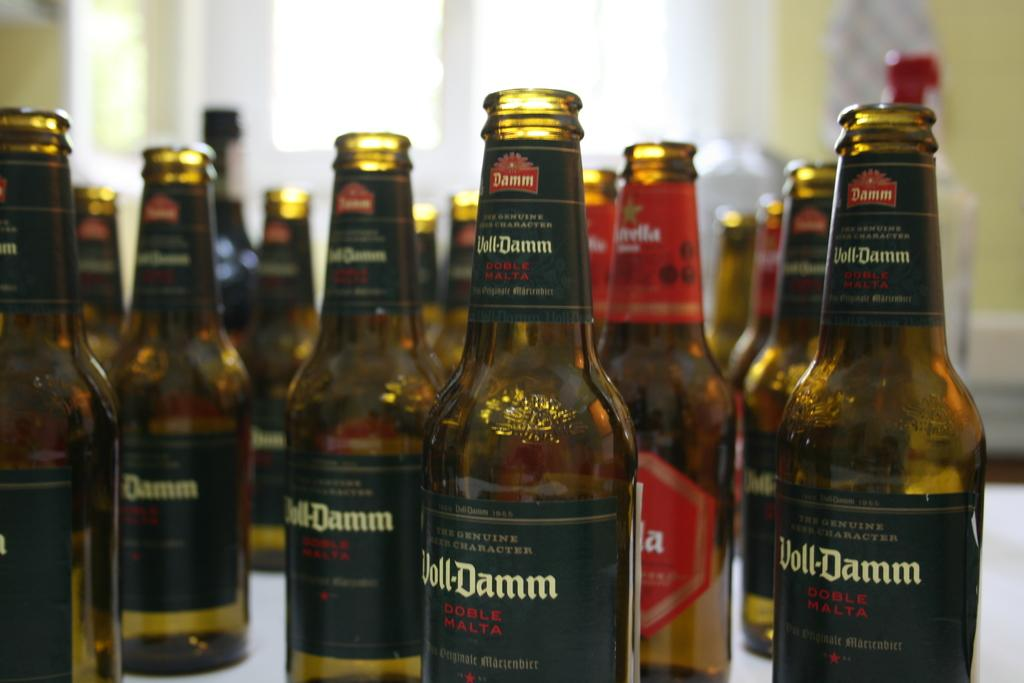Provide a one-sentence caption for the provided image. Many bottles of Doll-Damm next to one another. 